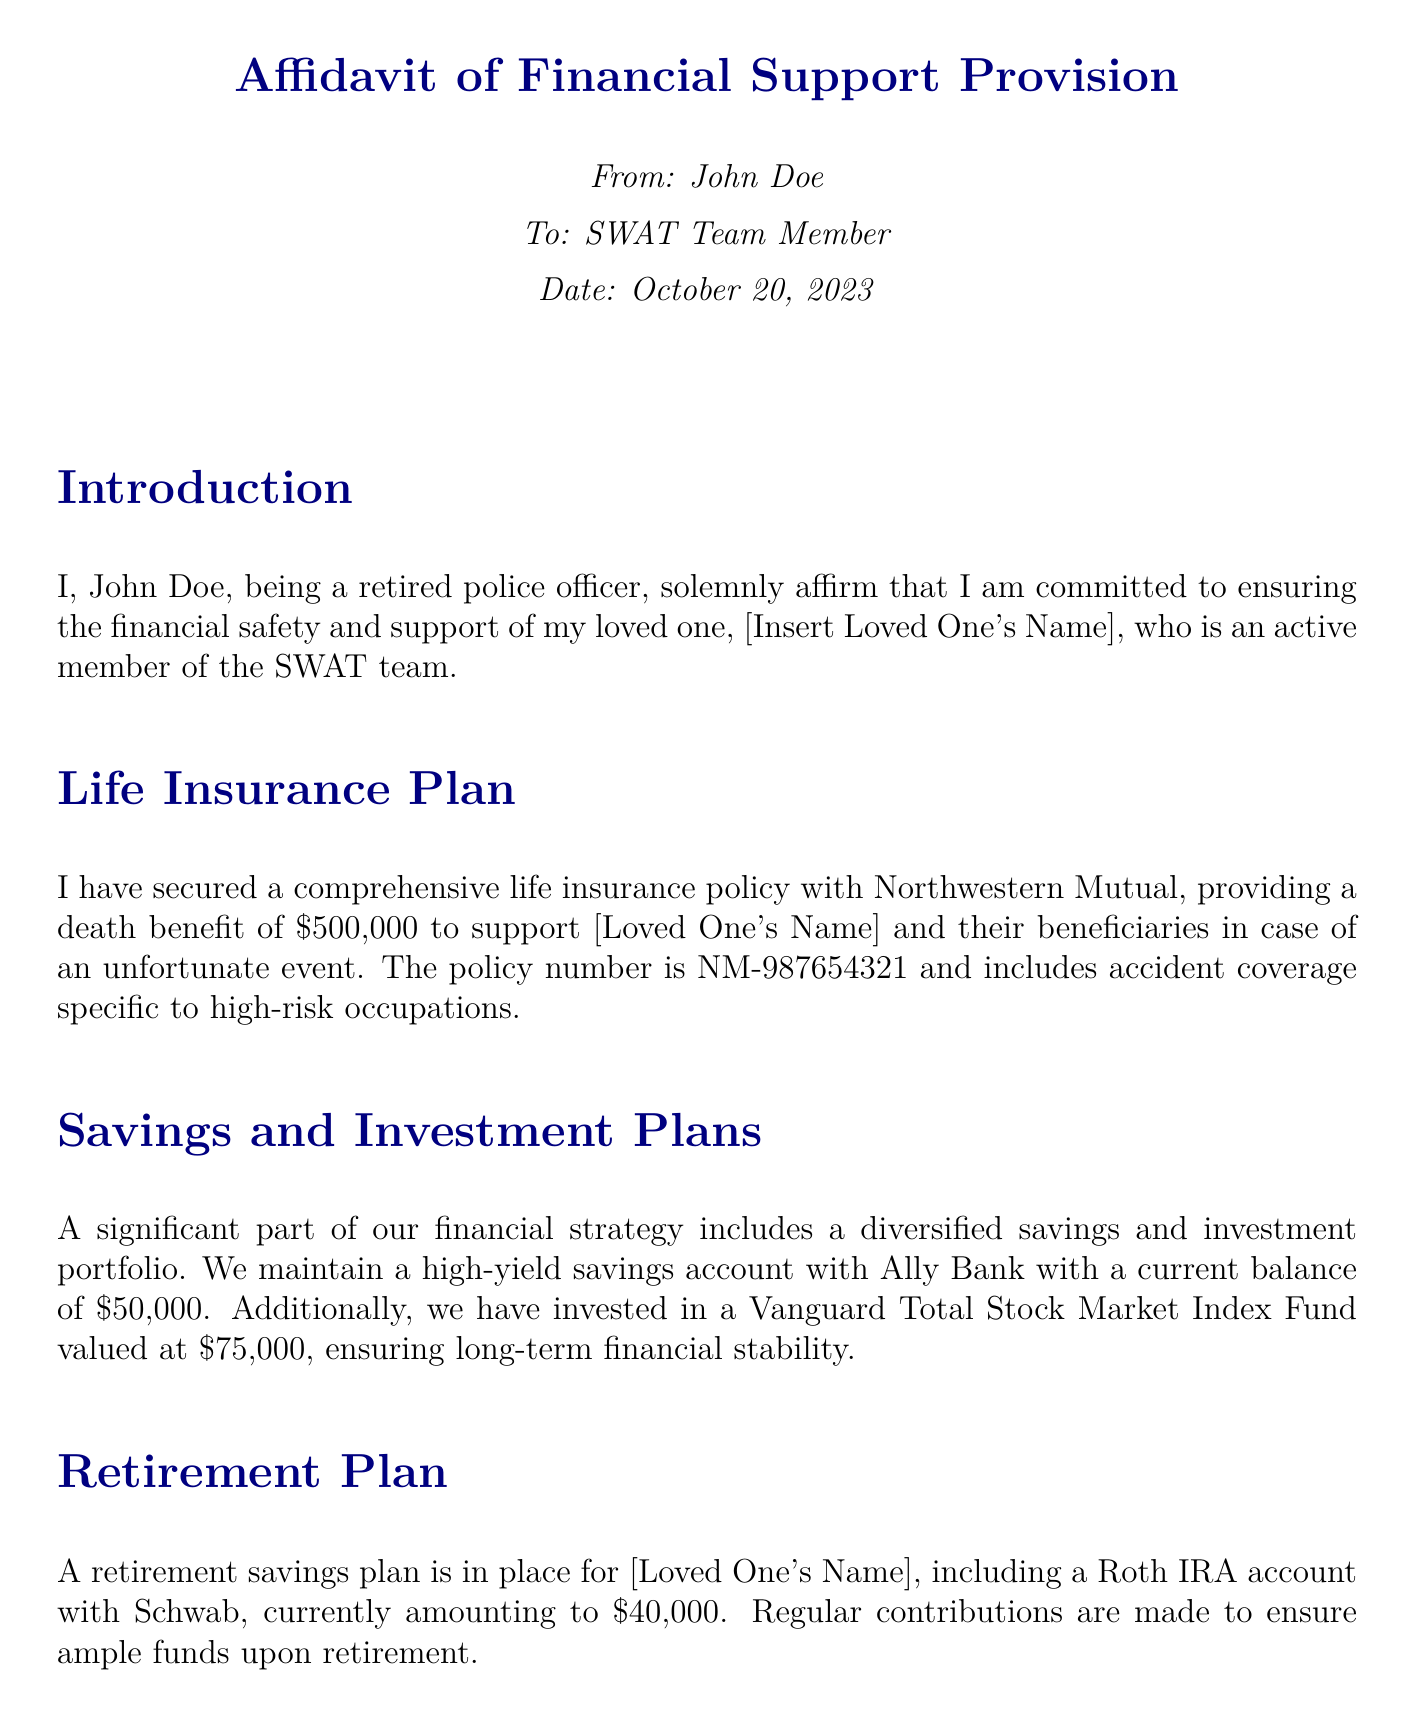what is the name of the insurance company? The insurance company providing life insurance is mentioned in the document as Northwestern Mutual.
Answer: Northwestern Mutual what is the death benefit amount of the life insurance policy? The affidavit specifies a death benefit of $500,000 associated with the life insurance policy.
Answer: $500,000 how much is currently in the high-yield savings account? The document states that the high-yield savings account with Ally Bank has a current balance of $50,000.
Answer: $50,000 what is the balance of the Vanguard Total Stock Market Index Fund? The balance of the Vanguard Total Stock Market Index Fund mentioned in the affidavit is $75,000.
Answer: $75,000 how much is in the emergency fund? According to the document, the emergency fund in a Chase savings account amounts to $20,000.
Answer: $20,000 what type of retirement account is mentioned in the affidavit? The affidavit describes a Roth IRA account as the type of retirement savings plan in place.
Answer: Roth IRA who provides health insurance coverage? The health insurance mentioned in the affidavit is provided by Aetna.
Answer: Aetna what firm is mentioned for legal support? The affidavit states that legal support and estate planning have been arranged with Smith & Associates.
Answer: Smith & Associates what is the primary purpose of the affidavit? The main purpose outlined in the affidavit is to ensure the financial safety and support for the loved one on the SWAT team.
Answer: To ensure financial safety and support 